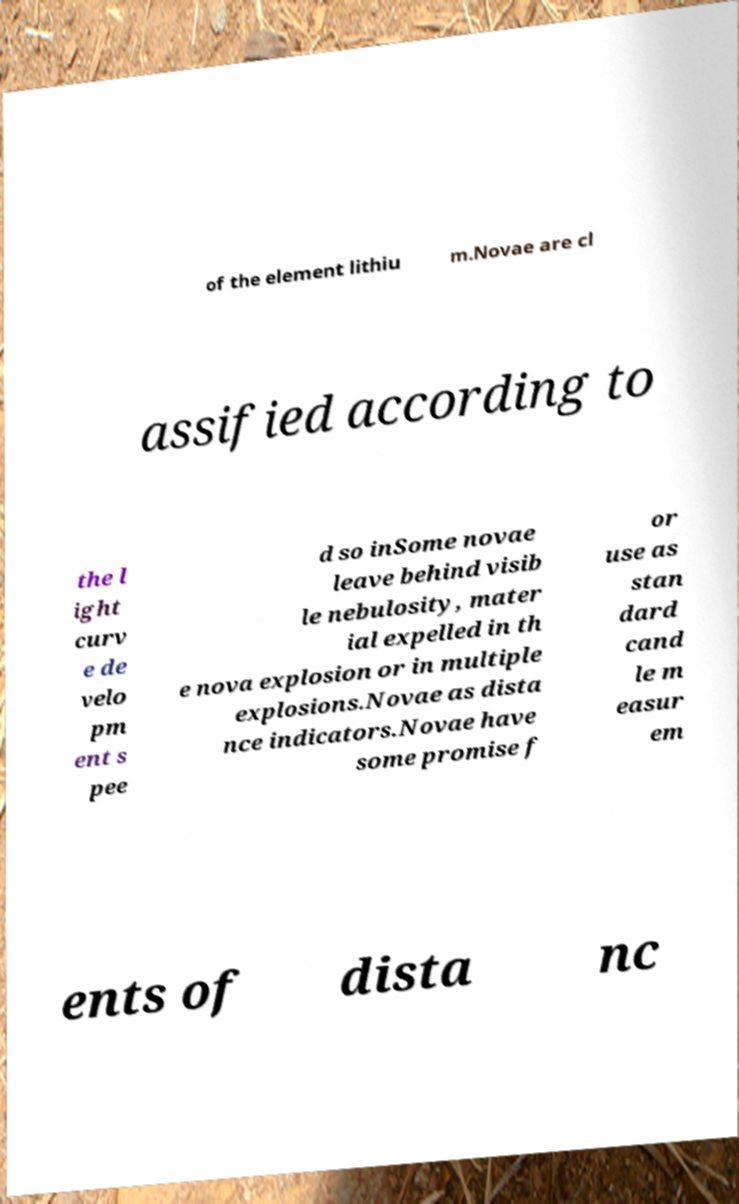There's text embedded in this image that I need extracted. Can you transcribe it verbatim? of the element lithiu m.Novae are cl assified according to the l ight curv e de velo pm ent s pee d so inSome novae leave behind visib le nebulosity, mater ial expelled in th e nova explosion or in multiple explosions.Novae as dista nce indicators.Novae have some promise f or use as stan dard cand le m easur em ents of dista nc 